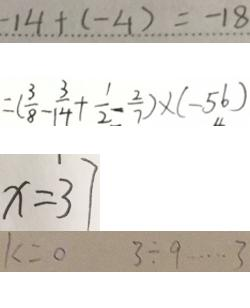Convert formula to latex. <formula><loc_0><loc_0><loc_500><loc_500>- 1 4 + ( - 4 ) = - 1 8 
 = ( \frac { 3 } { 8 } - \frac { 3 } { 1 4 } + \frac { 1 } { 2 } - \frac { 2 } { 7 } ) \times ( - 5 6 ) 
 x = 3 7 
 k = 0 3 \div 9 \cdots 3</formula> 